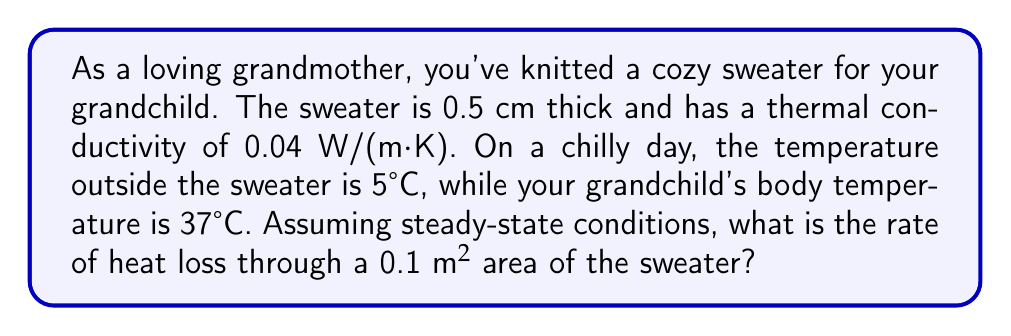Help me with this question. Let's approach this step-by-step using Fourier's law of heat conduction:

1) The formula for heat flow rate (Q) is:
   $$ Q = -kA\frac{dT}{dx} $$
   Where:
   - k is the thermal conductivity
   - A is the area
   - dT/dx is the temperature gradient

2) We're given:
   - k = 0.04 W/(m·K)
   - A = 0.1 m²
   - Thickness (dx) = 0.5 cm = 0.005 m
   - T_outside = 5°C
   - T_body = 37°C

3) Calculate the temperature gradient:
   $$ \frac{dT}{dx} = \frac{T_{outside} - T_{body}}{dx} = \frac{5°C - 37°C}{0.005 \text{ m}} = -6400 \text{ K/m} $$

4) Now, let's substitute these values into our heat flow equation:
   $$ Q = -(0.04 \text{ W/(m·K)})(0.1 \text{ m²})(-6400 \text{ K/m}) $$

5) Simplify:
   $$ Q = 25.6 \text{ W} $$

This means the rate of heat loss through the sweater is 25.6 watts.
Answer: 25.6 W 